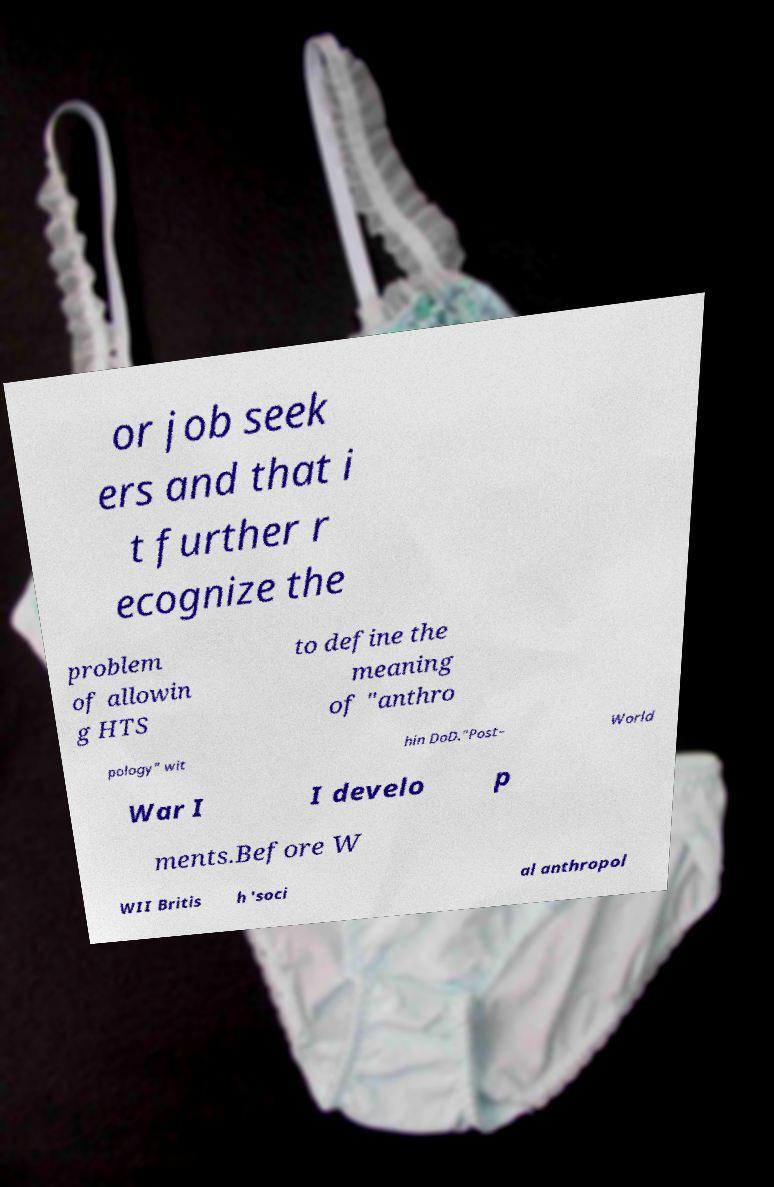Can you read and provide the text displayed in the image?This photo seems to have some interesting text. Can you extract and type it out for me? or job seek ers and that i t further r ecognize the problem of allowin g HTS to define the meaning of "anthro pology" wit hin DoD."Post– World War I I develo p ments.Before W WII Britis h 'soci al anthropol 